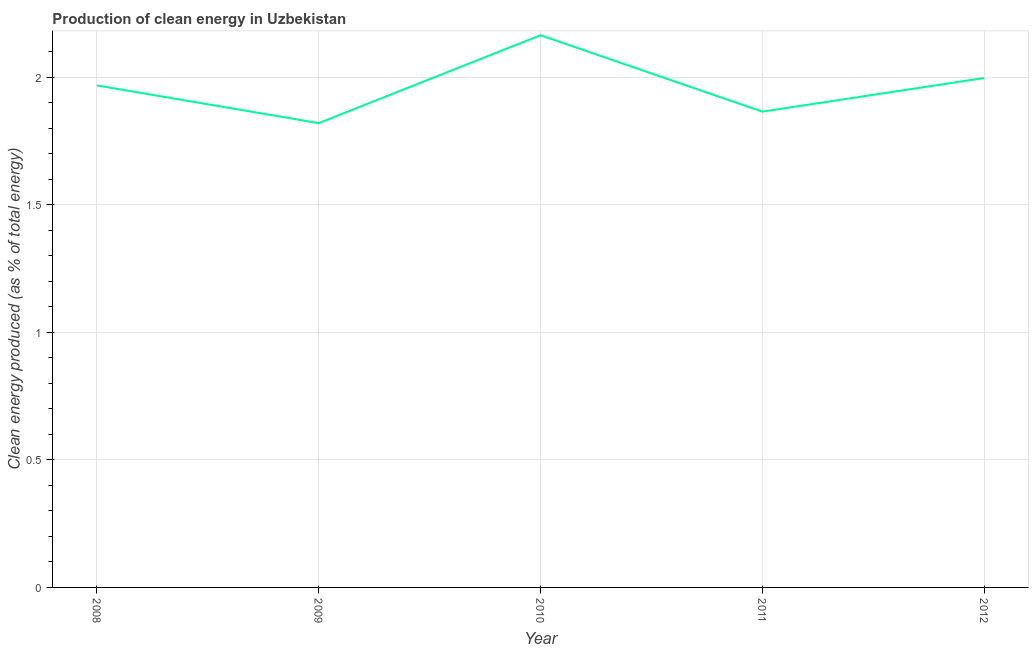What is the production of clean energy in 2010?
Give a very brief answer. 2.16. Across all years, what is the maximum production of clean energy?
Your response must be concise. 2.16. Across all years, what is the minimum production of clean energy?
Offer a terse response. 1.82. What is the sum of the production of clean energy?
Offer a very short reply. 9.81. What is the difference between the production of clean energy in 2008 and 2010?
Offer a very short reply. -0.2. What is the average production of clean energy per year?
Provide a short and direct response. 1.96. What is the median production of clean energy?
Offer a terse response. 1.97. Do a majority of the years between 2009 and 2012 (inclusive) have production of clean energy greater than 1.2 %?
Ensure brevity in your answer.  Yes. What is the ratio of the production of clean energy in 2008 to that in 2010?
Keep it short and to the point. 0.91. Is the production of clean energy in 2009 less than that in 2011?
Your answer should be compact. Yes. What is the difference between the highest and the second highest production of clean energy?
Make the answer very short. 0.17. Is the sum of the production of clean energy in 2009 and 2011 greater than the maximum production of clean energy across all years?
Provide a succinct answer. Yes. What is the difference between the highest and the lowest production of clean energy?
Keep it short and to the point. 0.34. In how many years, is the production of clean energy greater than the average production of clean energy taken over all years?
Provide a short and direct response. 3. How many years are there in the graph?
Offer a terse response. 5. What is the difference between two consecutive major ticks on the Y-axis?
Provide a short and direct response. 0.5. Are the values on the major ticks of Y-axis written in scientific E-notation?
Ensure brevity in your answer.  No. Does the graph contain grids?
Keep it short and to the point. Yes. What is the title of the graph?
Your answer should be compact. Production of clean energy in Uzbekistan. What is the label or title of the X-axis?
Your answer should be compact. Year. What is the label or title of the Y-axis?
Your response must be concise. Clean energy produced (as % of total energy). What is the Clean energy produced (as % of total energy) in 2008?
Offer a very short reply. 1.97. What is the Clean energy produced (as % of total energy) in 2009?
Give a very brief answer. 1.82. What is the Clean energy produced (as % of total energy) of 2010?
Offer a very short reply. 2.16. What is the Clean energy produced (as % of total energy) of 2011?
Offer a very short reply. 1.86. What is the Clean energy produced (as % of total energy) of 2012?
Offer a terse response. 2. What is the difference between the Clean energy produced (as % of total energy) in 2008 and 2009?
Offer a very short reply. 0.15. What is the difference between the Clean energy produced (as % of total energy) in 2008 and 2010?
Ensure brevity in your answer.  -0.2. What is the difference between the Clean energy produced (as % of total energy) in 2008 and 2011?
Offer a very short reply. 0.1. What is the difference between the Clean energy produced (as % of total energy) in 2008 and 2012?
Give a very brief answer. -0.03. What is the difference between the Clean energy produced (as % of total energy) in 2009 and 2010?
Give a very brief answer. -0.34. What is the difference between the Clean energy produced (as % of total energy) in 2009 and 2011?
Offer a terse response. -0.05. What is the difference between the Clean energy produced (as % of total energy) in 2009 and 2012?
Keep it short and to the point. -0.18. What is the difference between the Clean energy produced (as % of total energy) in 2010 and 2011?
Your response must be concise. 0.3. What is the difference between the Clean energy produced (as % of total energy) in 2010 and 2012?
Your answer should be very brief. 0.17. What is the difference between the Clean energy produced (as % of total energy) in 2011 and 2012?
Make the answer very short. -0.13. What is the ratio of the Clean energy produced (as % of total energy) in 2008 to that in 2009?
Provide a succinct answer. 1.08. What is the ratio of the Clean energy produced (as % of total energy) in 2008 to that in 2010?
Give a very brief answer. 0.91. What is the ratio of the Clean energy produced (as % of total energy) in 2008 to that in 2011?
Your response must be concise. 1.05. What is the ratio of the Clean energy produced (as % of total energy) in 2008 to that in 2012?
Keep it short and to the point. 0.98. What is the ratio of the Clean energy produced (as % of total energy) in 2009 to that in 2010?
Keep it short and to the point. 0.84. What is the ratio of the Clean energy produced (as % of total energy) in 2009 to that in 2011?
Offer a terse response. 0.98. What is the ratio of the Clean energy produced (as % of total energy) in 2009 to that in 2012?
Keep it short and to the point. 0.91. What is the ratio of the Clean energy produced (as % of total energy) in 2010 to that in 2011?
Give a very brief answer. 1.16. What is the ratio of the Clean energy produced (as % of total energy) in 2010 to that in 2012?
Make the answer very short. 1.08. What is the ratio of the Clean energy produced (as % of total energy) in 2011 to that in 2012?
Provide a short and direct response. 0.93. 